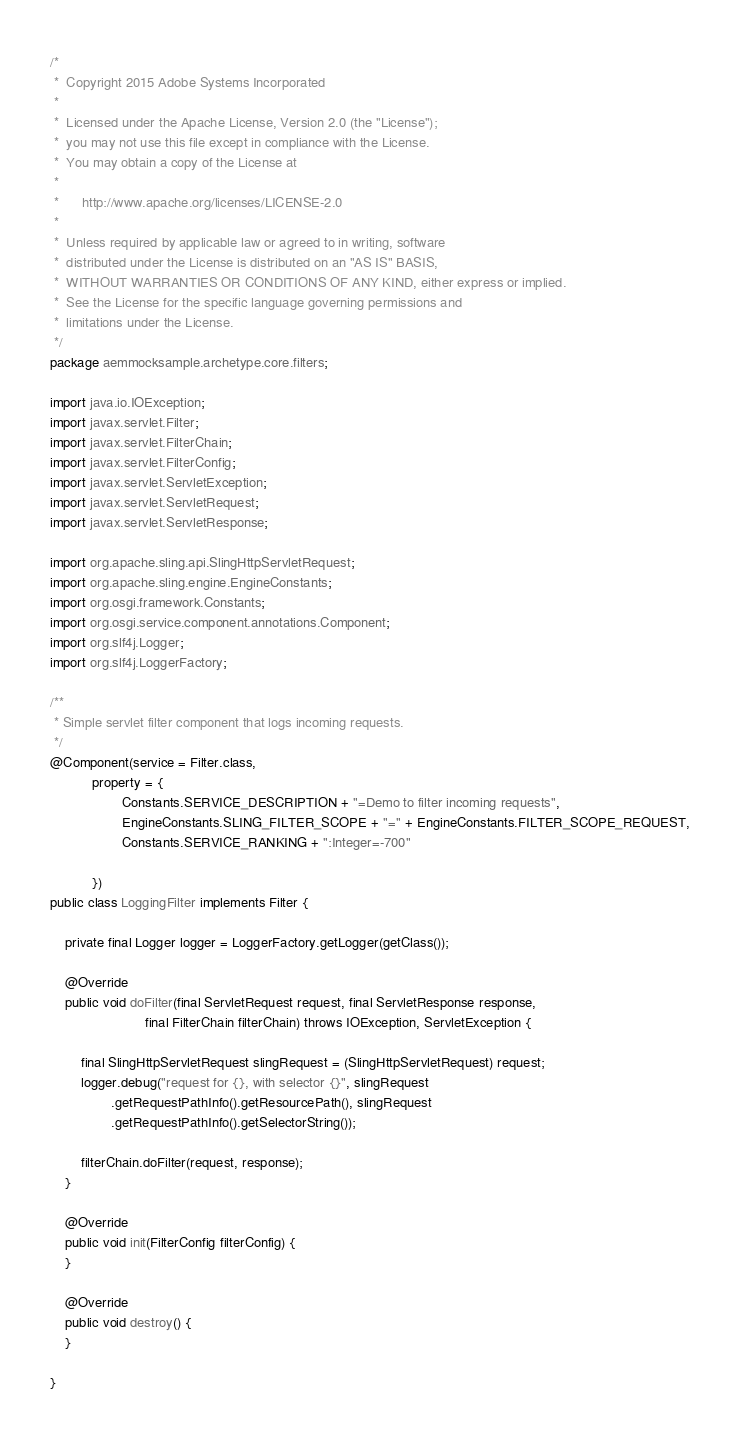<code> <loc_0><loc_0><loc_500><loc_500><_Java_>/*
 *  Copyright 2015 Adobe Systems Incorporated
 *
 *  Licensed under the Apache License, Version 2.0 (the "License");
 *  you may not use this file except in compliance with the License.
 *  You may obtain a copy of the License at
 *
 *      http://www.apache.org/licenses/LICENSE-2.0
 *
 *  Unless required by applicable law or agreed to in writing, software
 *  distributed under the License is distributed on an "AS IS" BASIS,
 *  WITHOUT WARRANTIES OR CONDITIONS OF ANY KIND, either express or implied.
 *  See the License for the specific language governing permissions and
 *  limitations under the License.
 */
package aemmocksample.archetype.core.filters;

import java.io.IOException;
import javax.servlet.Filter;
import javax.servlet.FilterChain;
import javax.servlet.FilterConfig;
import javax.servlet.ServletException;
import javax.servlet.ServletRequest;
import javax.servlet.ServletResponse;

import org.apache.sling.api.SlingHttpServletRequest;
import org.apache.sling.engine.EngineConstants;
import org.osgi.framework.Constants;
import org.osgi.service.component.annotations.Component;
import org.slf4j.Logger;
import org.slf4j.LoggerFactory;

/**
 * Simple servlet filter component that logs incoming requests.
 */
@Component(service = Filter.class,
           property = {
                   Constants.SERVICE_DESCRIPTION + "=Demo to filter incoming requests",
                   EngineConstants.SLING_FILTER_SCOPE + "=" + EngineConstants.FILTER_SCOPE_REQUEST,
                   Constants.SERVICE_RANKING + ":Integer=-700"

           })
public class LoggingFilter implements Filter {

    private final Logger logger = LoggerFactory.getLogger(getClass());

    @Override
    public void doFilter(final ServletRequest request, final ServletResponse response,
                         final FilterChain filterChain) throws IOException, ServletException {

        final SlingHttpServletRequest slingRequest = (SlingHttpServletRequest) request;
        logger.debug("request for {}, with selector {}", slingRequest
                .getRequestPathInfo().getResourcePath(), slingRequest
                .getRequestPathInfo().getSelectorString());

        filterChain.doFilter(request, response);
    }

    @Override
    public void init(FilterConfig filterConfig) {
    }

    @Override
    public void destroy() {
    }

}</code> 